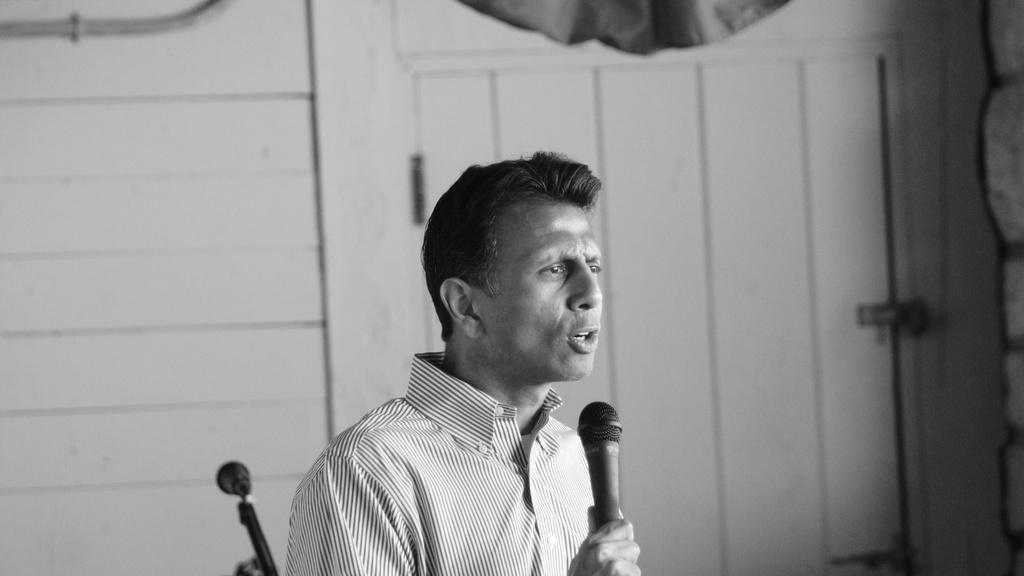What is the main subject of the image? There is a person in the image. What is the person holding in his hands? The person is holding a microphone in his hands. What can be seen in the background of the image? There is a wall in the background of the image. How many teeth can be seen in the image? There are no teeth visible in the image, as it features a person holding a microphone and a wall in the background. 